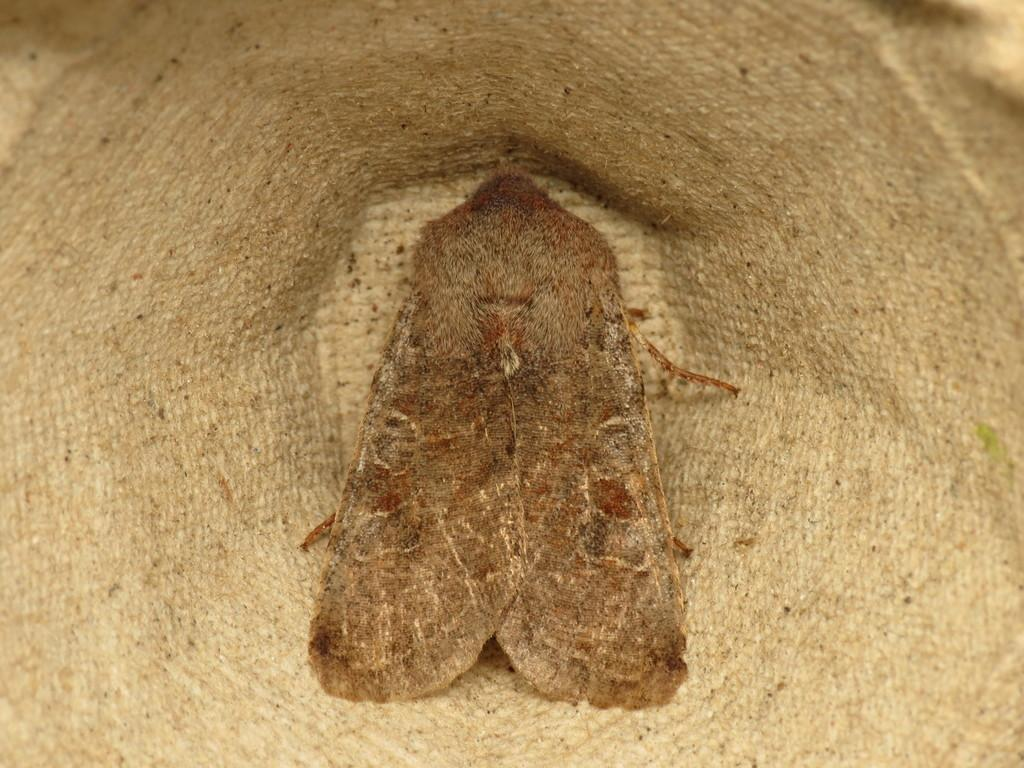What is present in the image? There is a fly in the image. Where is the fly located? The fly is inside a woven basket. What does the queen say when she sees the fly sneeze in the image? There is no queen or sneezing fly present in the image. 